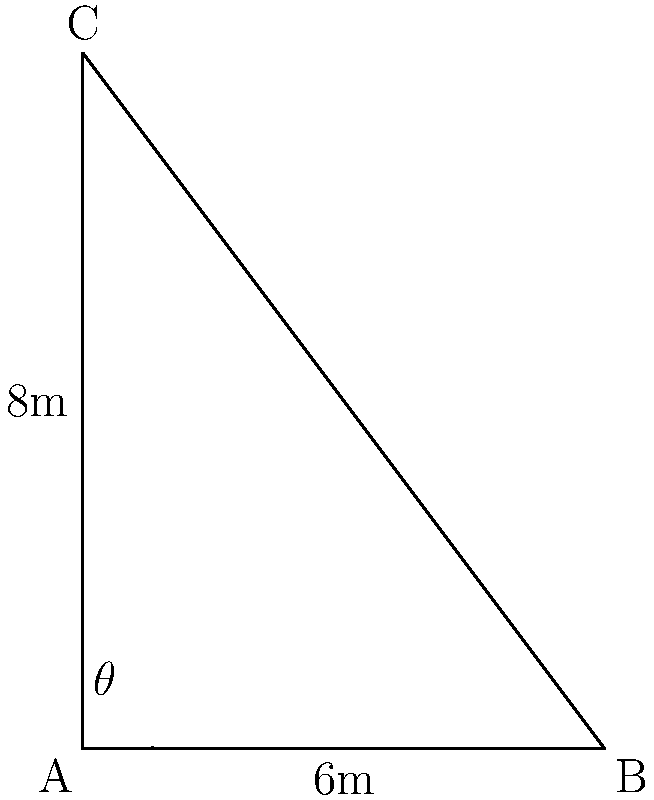On the Purga, you're tasked with measuring a triangular sail. The boom (bottom edge) measures 6 meters, and the mast (vertical edge) is 8 meters tall. What is the area of the sail in square meters? Round your answer to the nearest whole number. Let's approach this step-by-step:

1) We have a right-angled triangle, where:
   - The base (boom) is 6 meters
   - The height (mast) is 8 meters

2) To find the area of a triangle, we use the formula:
   $$ \text{Area} = \frac{1}{2} \times \text{base} \times \text{height} $$

3) Substituting our known values:
   $$ \text{Area} = \frac{1}{2} \times 6 \times 8 $$

4) Calculating:
   $$ \text{Area} = \frac{1}{2} \times 48 = 24 $$

5) Therefore, the area of the sail is 24 square meters.

Note: While we could have used trigonometric ratios to solve this problem (by finding the angle $\theta$ and then using $\frac{1}{2}ab\sin(C)$), it wasn't necessary in this case as we already had the base and height of the right-angled triangle.
Answer: 24 sq m 